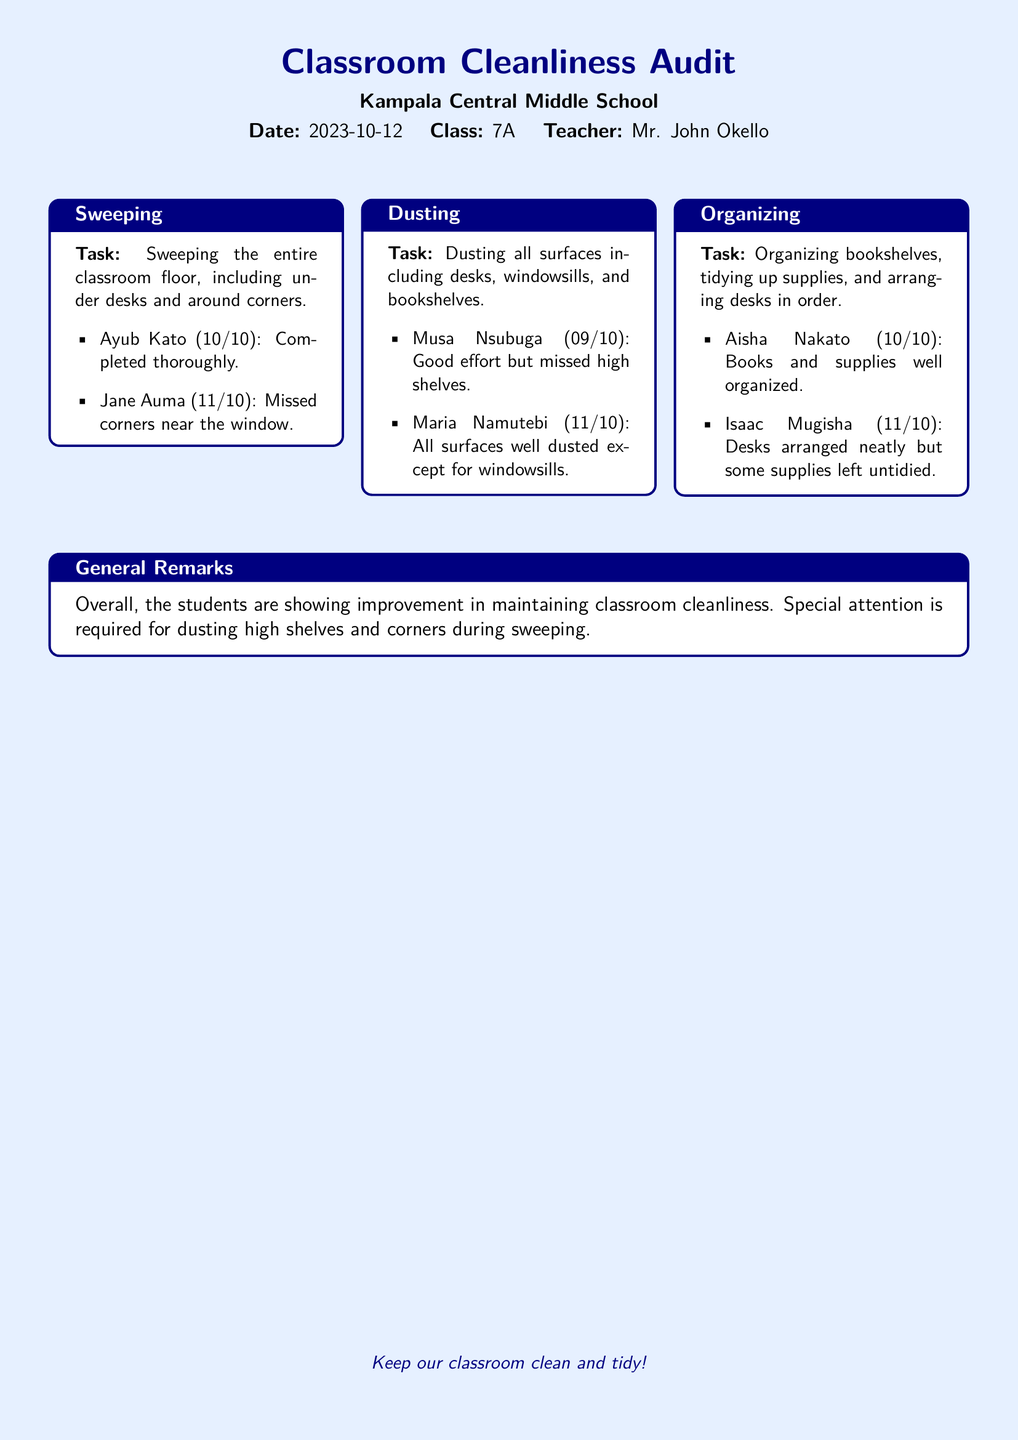What is the date of the audit? The date of the audit is provided at the beginning of the document, which states "Date: 2023-10-12."
Answer: 2023-10-12 Who is the teacher for class 7A? The document mentions "Teacher: Mr. John Okello" indicating who the teacher is for class 7A.
Answer: Mr. John Okello What score did Musa Nsubuga receive for dusting? The document lists "Musa Nsubuga (09/10): Good effort," which indicates his score for dusting.
Answer: 09/10 Which task had a remark about high shelves? The dusting task includes a remark about "missed high shelves," indicating an area of improvement.
Answer: Dusting Who organized the books and supplies well? The organizational task mentions "Aisha Nakato (10/10): Books and supplies well organized."
Answer: Aisha Nakato What was noted in the general remarks about maintaining cleanliness? The general remarks mention "Overall, the students are showing improvement," reflecting their performance.
Answer: Improvement What is one specific area that requires attention during sweeping? The general remarks indicate that "corners" require special attention during sweeping.
Answer: Corners Which student missed corners near the window while sweeping? In the sweeping section, it states "Jane Auma (11/10): Missed corners near the window," addressing her performance.
Answer: Jane Auma 